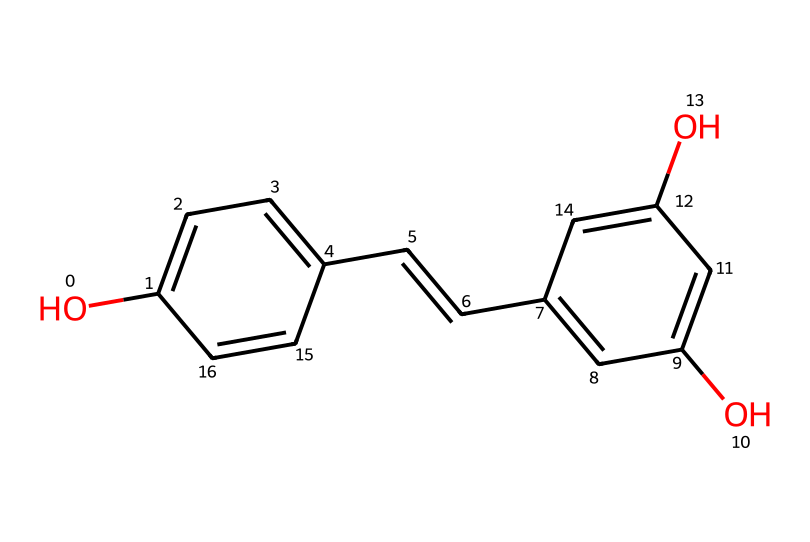What is the molecular formula of resveratrol? The molecular formula can be determined by counting the number of each type of atom in the chemical structure. From the SMILES representation, we can see it contains 14 carbon atoms (C), 12 hydrogen atoms (H), and 4 oxygen atoms (O), leading to the formula C14H12O4.
Answer: C14H12O4 How many hydroxyl groups are present in resveratrol? By analyzing the chemical structure, we identify the -OH (hydroxyl) groups represented. There are two -OH groups attached to the phenolic rings, confirming there are two hydroxyl groups in the structure.
Answer: 2 What type of chemical compound is resveratrol classified as? Resveratrol is classified by examining the structure and identifying the presence of certain functional groups. It is a polyphenol due to the multiple phenolic structures present in its molecular design.
Answer: polyphenol Which part of the resveratrol molecule contributes to its antioxidant properties? The presence of the phenolic hydroxyl groups is significant in conferring antioxidant properties; these are able to donate hydrogen atoms and stabilize free radicals. Thus, the outer -OH groups are critical for these properties.
Answer: phenolic hydroxyl groups What is the relationship between the double bonds and reactivity in resveratrol? The presence of the double bonds in the molecular structure indicates sites of unsaturation in the compound. These double bonds can make the molecule more reactive compared to saturated compounds due to increased electron density and the ability to participate in addition reactions. Hence, resveratrol has sites that are reactive due to these double bonds.
Answer: double bonds 